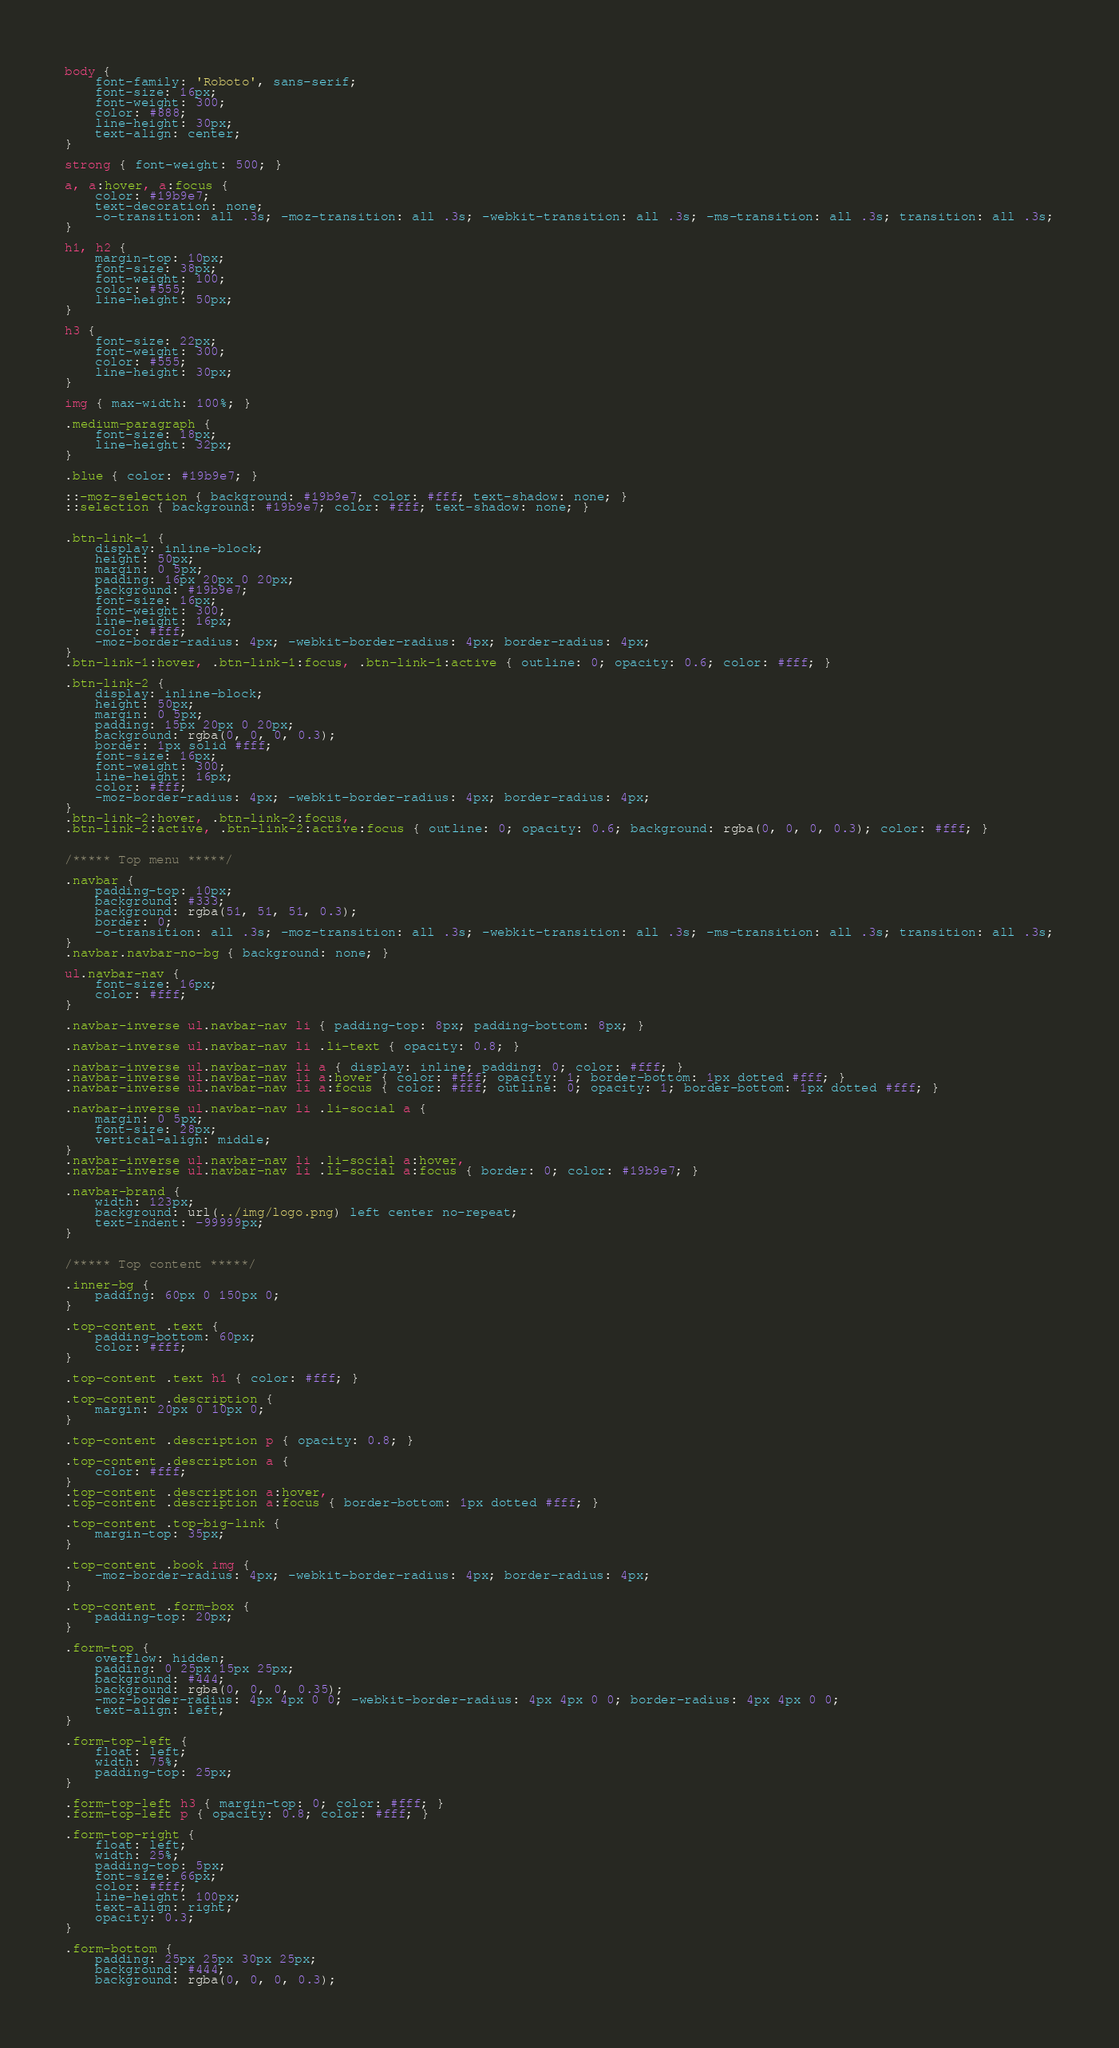<code> <loc_0><loc_0><loc_500><loc_500><_CSS_>
body {
    font-family: 'Roboto', sans-serif;
    font-size: 16px;
    font-weight: 300;
    color: #888;
    line-height: 30px;
    text-align: center;
}

strong { font-weight: 500; }

a, a:hover, a:focus {
	color: #19b9e7;
	text-decoration: none;
    -o-transition: all .3s; -moz-transition: all .3s; -webkit-transition: all .3s; -ms-transition: all .3s; transition: all .3s;
}

h1, h2 {
	margin-top: 10px;
	font-size: 38px;
    font-weight: 100;
    color: #555;
    line-height: 50px;
}

h3 {
	font-size: 22px;
    font-weight: 300;
    color: #555;
    line-height: 30px;
}

img { max-width: 100%; }

.medium-paragraph {
	font-size: 18px;
	line-height: 32px;
}

.blue { color: #19b9e7; }

::-moz-selection { background: #19b9e7; color: #fff; text-shadow: none; }
::selection { background: #19b9e7; color: #fff; text-shadow: none; }


.btn-link-1 {
	display: inline-block;
	height: 50px;
	margin: 0 5px;
	padding: 16px 20px 0 20px;
	background: #19b9e7;
	font-size: 16px;
    font-weight: 300;
    line-height: 16px;
    color: #fff;
    -moz-border-radius: 4px; -webkit-border-radius: 4px; border-radius: 4px;
}
.btn-link-1:hover, .btn-link-1:focus, .btn-link-1:active { outline: 0; opacity: 0.6; color: #fff; }

.btn-link-2 {
	display: inline-block;
	height: 50px;
	margin: 0 5px;
	padding: 15px 20px 0 20px;
	background: rgba(0, 0, 0, 0.3);
	border: 1px solid #fff;
	font-size: 16px;
    font-weight: 300;
    line-height: 16px;
    color: #fff;
    -moz-border-radius: 4px; -webkit-border-radius: 4px; border-radius: 4px;
}
.btn-link-2:hover, .btn-link-2:focus, 
.btn-link-2:active, .btn-link-2:active:focus { outline: 0; opacity: 0.6; background: rgba(0, 0, 0, 0.3); color: #fff; }


/***** Top menu *****/

.navbar {
	padding-top: 10px;
	background: #333;
	background: rgba(51, 51, 51, 0.3);
	border: 0;
	-o-transition: all .3s; -moz-transition: all .3s; -webkit-transition: all .3s; -ms-transition: all .3s; transition: all .3s;
}
.navbar.navbar-no-bg { background: none; }

ul.navbar-nav {
	font-size: 16px;
	color: #fff;
}

.navbar-inverse ul.navbar-nav li { padding-top: 8px; padding-bottom: 8px; }

.navbar-inverse ul.navbar-nav li .li-text { opacity: 0.8; }

.navbar-inverse ul.navbar-nav li a { display: inline; padding: 0; color: #fff; }
.navbar-inverse ul.navbar-nav li a:hover { color: #fff; opacity: 1; border-bottom: 1px dotted #fff; }
.navbar-inverse ul.navbar-nav li a:focus { color: #fff; outline: 0; opacity: 1; border-bottom: 1px dotted #fff; }

.navbar-inverse ul.navbar-nav li .li-social a {
	margin: 0 5px;
	font-size: 28px;
	vertical-align: middle;
}
.navbar-inverse ul.navbar-nav li .li-social a:hover, 
.navbar-inverse ul.navbar-nav li .li-social a:focus { border: 0; color: #19b9e7; }

.navbar-brand {
	width: 123px;
	background: url(../img/logo.png) left center no-repeat;
	text-indent: -99999px;
}


/***** Top content *****/

.inner-bg {
    padding: 60px 0 150px 0;
}

.top-content .text {
	padding-bottom: 60px;
	color: #fff;
}

.top-content .text h1 { color: #fff; }

.top-content .description {
	margin: 20px 0 10px 0;
}

.top-content .description p { opacity: 0.8; }

.top-content .description a {
	color: #fff;
}
.top-content .description a:hover, 
.top-content .description a:focus { border-bottom: 1px dotted #fff; }

.top-content .top-big-link {
	margin-top: 35px;
}

.top-content .book img {
	-moz-border-radius: 4px; -webkit-border-radius: 4px; border-radius: 4px;
}

.top-content .form-box {
	padding-top: 20px;
}

.form-top {
	overflow: hidden;
	padding: 0 25px 15px 25px;
	background: #444;
	background: rgba(0, 0, 0, 0.35);
	-moz-border-radius: 4px 4px 0 0; -webkit-border-radius: 4px 4px 0 0; border-radius: 4px 4px 0 0;
	text-align: left;
}

.form-top-left {
	float: left;
	width: 75%;
	padding-top: 25px;
}

.form-top-left h3 { margin-top: 0; color: #fff; }
.form-top-left p { opacity: 0.8; color: #fff; }

.form-top-right {
	float: left;
	width: 25%;
	padding-top: 5px;
	font-size: 66px;
	color: #fff;
	line-height: 100px;
	text-align: right;
	opacity: 0.3;
}

.form-bottom {
	padding: 25px 25px 30px 25px;
	background: #444;
	background: rgba(0, 0, 0, 0.3);</code> 